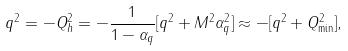Convert formula to latex. <formula><loc_0><loc_0><loc_500><loc_500>q ^ { 2 } = - Q _ { h } ^ { 2 } = - \frac { 1 } { 1 - \alpha _ { q } } [ { q } ^ { 2 } + M ^ { 2 } \alpha _ { q } ^ { 2 } ] \approx - [ { q } ^ { 2 } + Q _ { \min } ^ { 2 } ] ,</formula> 